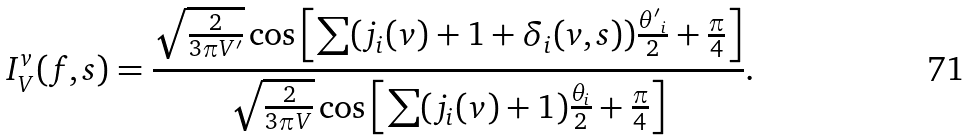Convert formula to latex. <formula><loc_0><loc_0><loc_500><loc_500>I _ { V } ^ { v } ( f , s ) = \frac { \sqrt { \frac { 2 } { 3 \pi V ^ { \prime } } } \cos \left [ \sum ( j _ { i } ( v ) + 1 + \delta _ { i } ( v , s ) ) \frac { { \theta ^ { \prime } } _ { i } } { 2 } + \frac { \pi } { 4 } \right ] } { \sqrt { \frac { 2 } { 3 \pi V } } \cos \left [ \sum ( j _ { i } ( v ) + 1 ) \frac { \theta _ { i } } { 2 } + \frac { \pi } { 4 } \right ] } .</formula> 